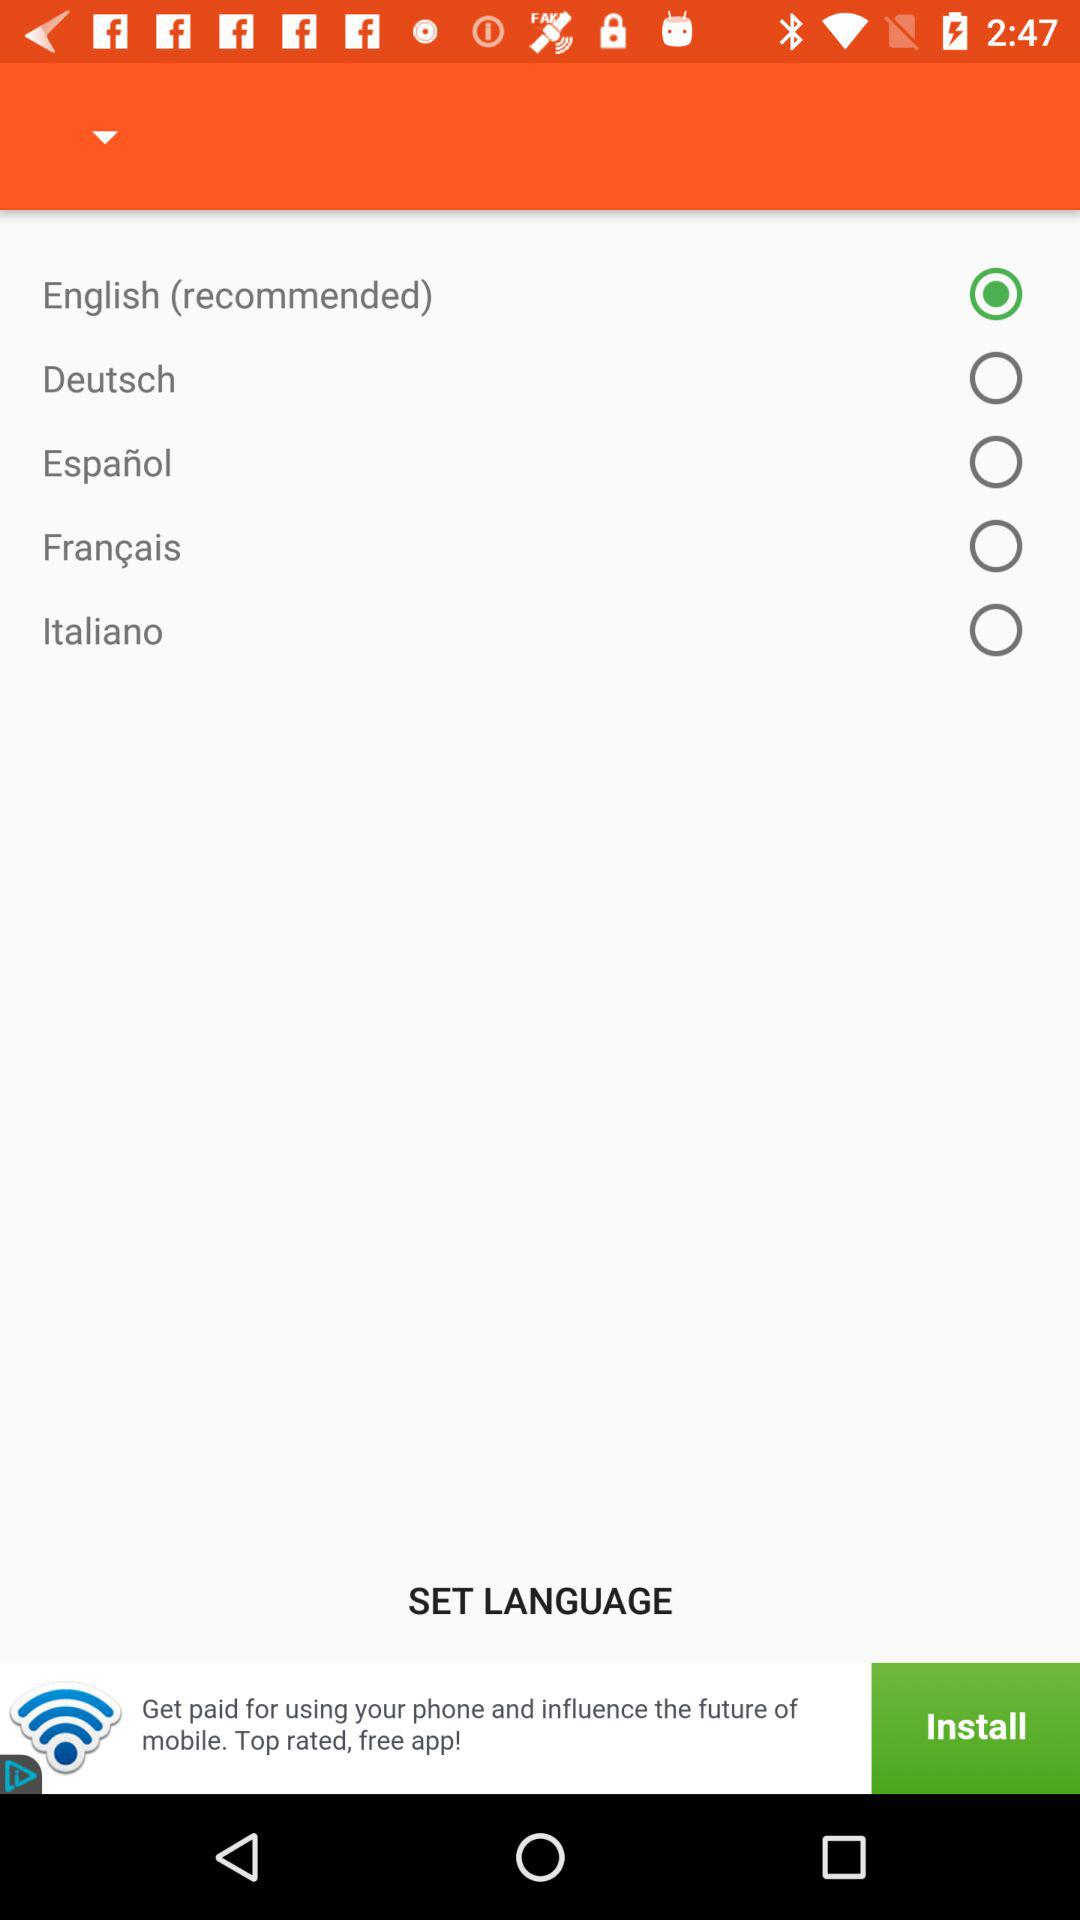Which language is selected? The selected language is "English". 